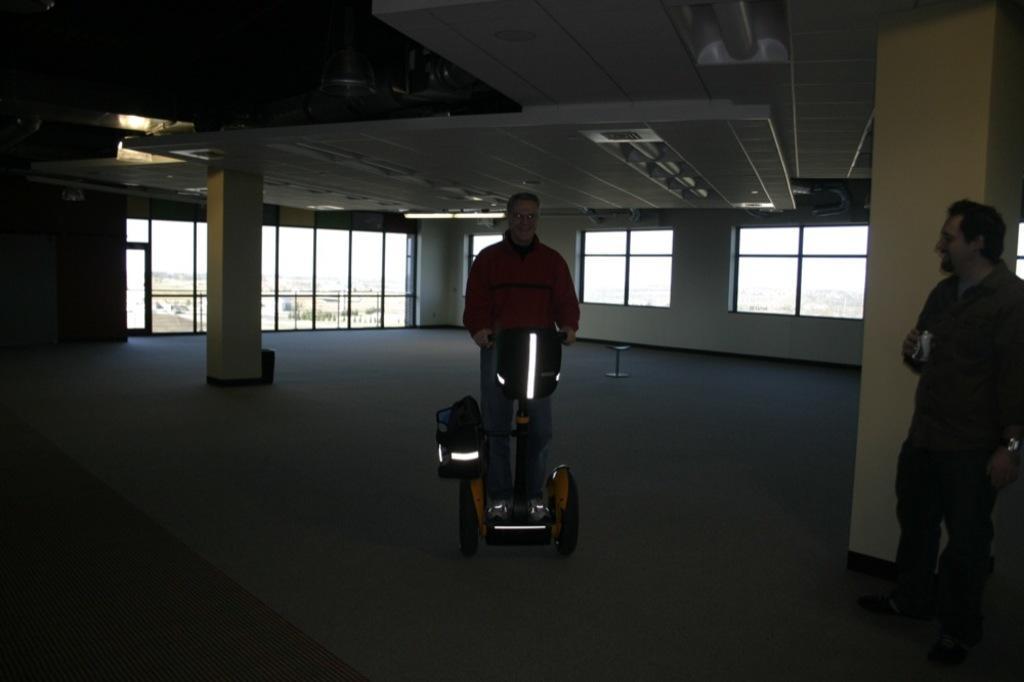Can you describe this image briefly? This picture shows the inner view of a building with glass windows, two objects on the floor, two pillars, one object looks like a carpet on the floor on the bottom left side of the image, few lights attached to the ceiling, some objects attached to the ceiling, one man standing and holding an object on the right side of the image. One man standing and riding the seaway on the floor. Through the glass windows we can see the buildings, some trees and at the top there is the sky. 